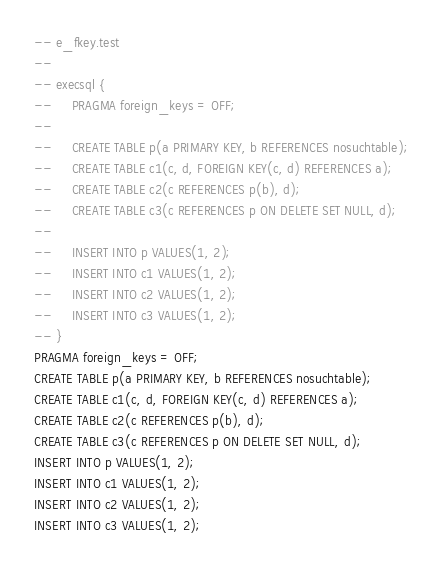<code> <loc_0><loc_0><loc_500><loc_500><_SQL_>-- e_fkey.test
-- 
-- execsql {
--     PRAGMA foreign_keys = OFF;
-- 
--     CREATE TABLE p(a PRIMARY KEY, b REFERENCES nosuchtable);
--     CREATE TABLE c1(c, d, FOREIGN KEY(c, d) REFERENCES a);
--     CREATE TABLE c2(c REFERENCES p(b), d);
--     CREATE TABLE c3(c REFERENCES p ON DELETE SET NULL, d);
-- 
--     INSERT INTO p VALUES(1, 2);
--     INSERT INTO c1 VALUES(1, 2);
--     INSERT INTO c2 VALUES(1, 2);
--     INSERT INTO c3 VALUES(1, 2);
-- }
PRAGMA foreign_keys = OFF;
CREATE TABLE p(a PRIMARY KEY, b REFERENCES nosuchtable);
CREATE TABLE c1(c, d, FOREIGN KEY(c, d) REFERENCES a);
CREATE TABLE c2(c REFERENCES p(b), d);
CREATE TABLE c3(c REFERENCES p ON DELETE SET NULL, d);
INSERT INTO p VALUES(1, 2);
INSERT INTO c1 VALUES(1, 2);
INSERT INTO c2 VALUES(1, 2);
INSERT INTO c3 VALUES(1, 2);</code> 